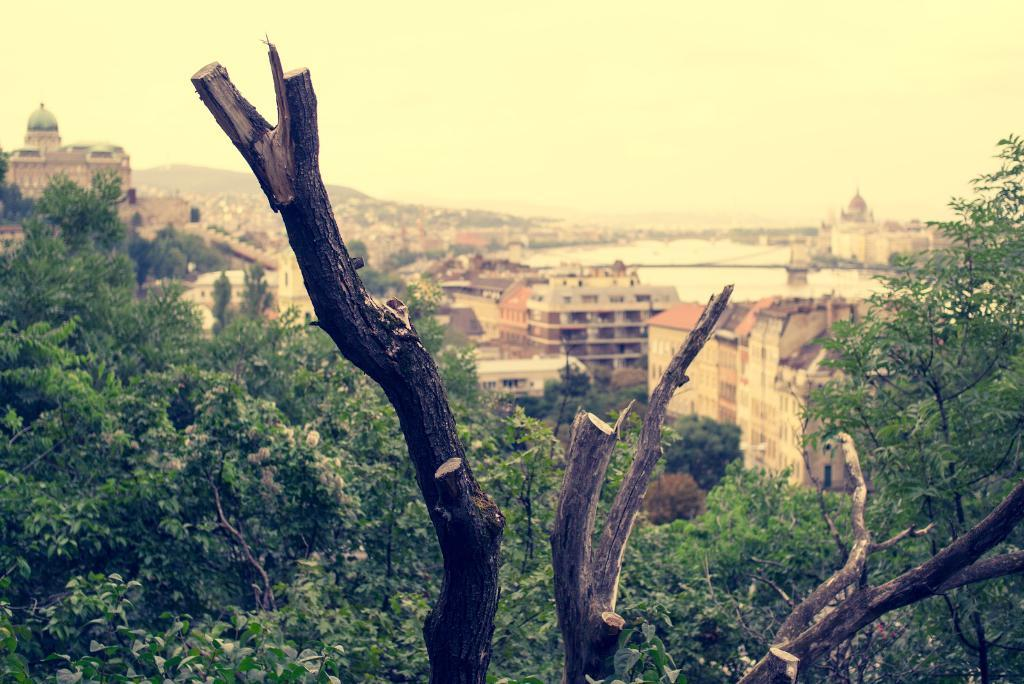What type of natural elements can be seen in the image? There are trees and branches visible in the image. What type of man-made structures can be seen in the image? There are buildings and a fort visible in the image. What type of terrain is present in the image? There is water visible in the image. What is the color of the sky in the image? The sky appears to be white in color. What type of secretary is present in the image? There is no secretary present in the image. What scientific theory can be observed in the image? There is no scientific theory depicted in the image. 